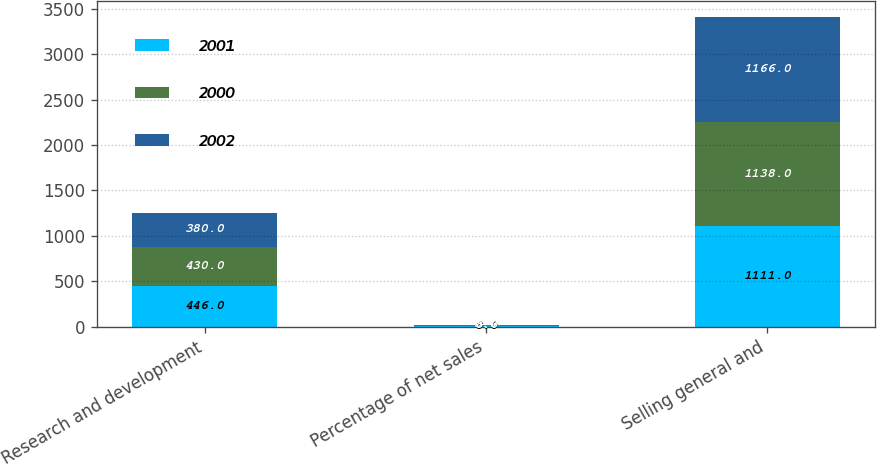Convert chart. <chart><loc_0><loc_0><loc_500><loc_500><stacked_bar_chart><ecel><fcel>Research and development<fcel>Percentage of net sales<fcel>Selling general and<nl><fcel>2001<fcel>446<fcel>8<fcel>1111<nl><fcel>2000<fcel>430<fcel>8<fcel>1138<nl><fcel>2002<fcel>380<fcel>5<fcel>1166<nl></chart> 